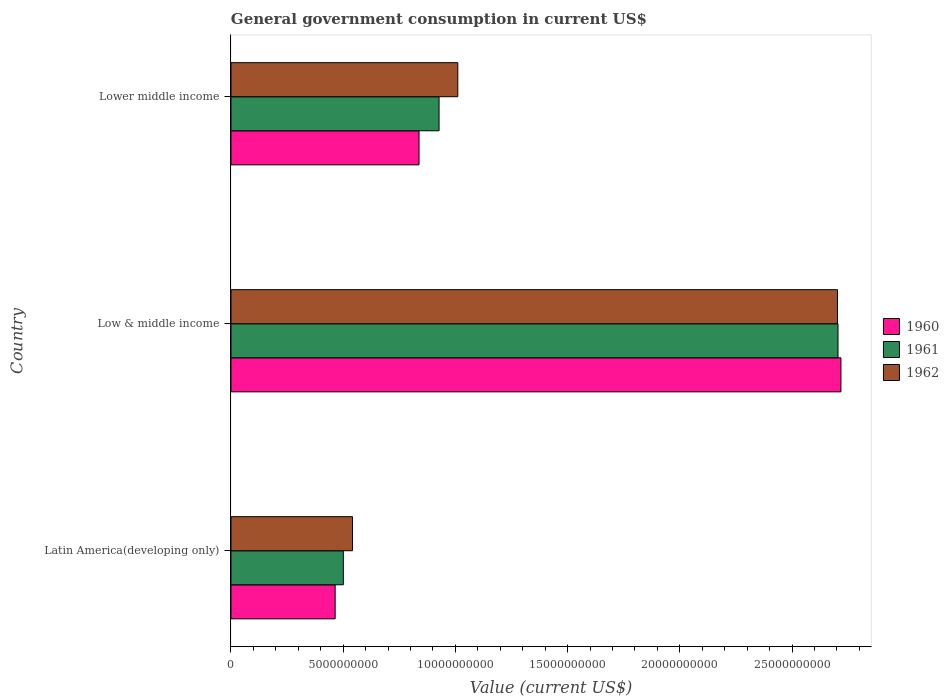How many different coloured bars are there?
Provide a short and direct response. 3. How many groups of bars are there?
Ensure brevity in your answer.  3. Are the number of bars per tick equal to the number of legend labels?
Offer a very short reply. Yes. How many bars are there on the 2nd tick from the top?
Make the answer very short. 3. How many bars are there on the 3rd tick from the bottom?
Provide a succinct answer. 3. What is the label of the 1st group of bars from the top?
Your answer should be very brief. Lower middle income. In how many cases, is the number of bars for a given country not equal to the number of legend labels?
Your answer should be very brief. 0. What is the government conusmption in 1962 in Latin America(developing only)?
Offer a terse response. 5.41e+09. Across all countries, what is the maximum government conusmption in 1960?
Your answer should be very brief. 2.72e+1. Across all countries, what is the minimum government conusmption in 1962?
Offer a terse response. 5.41e+09. In which country was the government conusmption in 1961 maximum?
Your answer should be very brief. Low & middle income. In which country was the government conusmption in 1960 minimum?
Give a very brief answer. Latin America(developing only). What is the total government conusmption in 1960 in the graph?
Keep it short and to the point. 4.02e+1. What is the difference between the government conusmption in 1960 in Latin America(developing only) and that in Lower middle income?
Offer a terse response. -3.74e+09. What is the difference between the government conusmption in 1961 in Latin America(developing only) and the government conusmption in 1962 in Low & middle income?
Ensure brevity in your answer.  -2.20e+1. What is the average government conusmption in 1962 per country?
Your answer should be very brief. 1.42e+1. What is the difference between the government conusmption in 1962 and government conusmption in 1961 in Latin America(developing only)?
Offer a terse response. 4.09e+08. What is the ratio of the government conusmption in 1961 in Low & middle income to that in Lower middle income?
Ensure brevity in your answer.  2.92. Is the government conusmption in 1962 in Low & middle income less than that in Lower middle income?
Give a very brief answer. No. Is the difference between the government conusmption in 1962 in Latin America(developing only) and Lower middle income greater than the difference between the government conusmption in 1961 in Latin America(developing only) and Lower middle income?
Your answer should be very brief. No. What is the difference between the highest and the second highest government conusmption in 1962?
Your answer should be compact. 1.69e+1. What is the difference between the highest and the lowest government conusmption in 1962?
Your response must be concise. 2.16e+1. In how many countries, is the government conusmption in 1960 greater than the average government conusmption in 1960 taken over all countries?
Make the answer very short. 1. Are all the bars in the graph horizontal?
Your answer should be compact. Yes. Are the values on the major ticks of X-axis written in scientific E-notation?
Ensure brevity in your answer.  No. Does the graph contain any zero values?
Your response must be concise. No. How are the legend labels stacked?
Give a very brief answer. Vertical. What is the title of the graph?
Give a very brief answer. General government consumption in current US$. What is the label or title of the X-axis?
Offer a terse response. Value (current US$). What is the Value (current US$) in 1960 in Latin America(developing only)?
Your answer should be compact. 4.64e+09. What is the Value (current US$) of 1961 in Latin America(developing only)?
Offer a terse response. 5.01e+09. What is the Value (current US$) in 1962 in Latin America(developing only)?
Offer a terse response. 5.41e+09. What is the Value (current US$) of 1960 in Low & middle income?
Provide a short and direct response. 2.72e+1. What is the Value (current US$) in 1961 in Low & middle income?
Keep it short and to the point. 2.70e+1. What is the Value (current US$) of 1962 in Low & middle income?
Make the answer very short. 2.70e+1. What is the Value (current US$) in 1960 in Lower middle income?
Ensure brevity in your answer.  8.38e+09. What is the Value (current US$) of 1961 in Lower middle income?
Offer a terse response. 9.27e+09. What is the Value (current US$) of 1962 in Lower middle income?
Ensure brevity in your answer.  1.01e+1. Across all countries, what is the maximum Value (current US$) in 1960?
Offer a terse response. 2.72e+1. Across all countries, what is the maximum Value (current US$) of 1961?
Your answer should be very brief. 2.70e+1. Across all countries, what is the maximum Value (current US$) of 1962?
Offer a very short reply. 2.70e+1. Across all countries, what is the minimum Value (current US$) in 1960?
Make the answer very short. 4.64e+09. Across all countries, what is the minimum Value (current US$) in 1961?
Your answer should be very brief. 5.01e+09. Across all countries, what is the minimum Value (current US$) of 1962?
Your answer should be very brief. 5.41e+09. What is the total Value (current US$) in 1960 in the graph?
Ensure brevity in your answer.  4.02e+1. What is the total Value (current US$) of 1961 in the graph?
Offer a terse response. 4.13e+1. What is the total Value (current US$) in 1962 in the graph?
Make the answer very short. 4.25e+1. What is the difference between the Value (current US$) in 1960 in Latin America(developing only) and that in Low & middle income?
Your response must be concise. -2.25e+1. What is the difference between the Value (current US$) of 1961 in Latin America(developing only) and that in Low & middle income?
Provide a succinct answer. -2.20e+1. What is the difference between the Value (current US$) of 1962 in Latin America(developing only) and that in Low & middle income?
Make the answer very short. -2.16e+1. What is the difference between the Value (current US$) in 1960 in Latin America(developing only) and that in Lower middle income?
Your answer should be very brief. -3.74e+09. What is the difference between the Value (current US$) in 1961 in Latin America(developing only) and that in Lower middle income?
Offer a terse response. -4.27e+09. What is the difference between the Value (current US$) of 1962 in Latin America(developing only) and that in Lower middle income?
Offer a very short reply. -4.69e+09. What is the difference between the Value (current US$) of 1960 in Low & middle income and that in Lower middle income?
Keep it short and to the point. 1.88e+1. What is the difference between the Value (current US$) of 1961 in Low & middle income and that in Lower middle income?
Offer a very short reply. 1.78e+1. What is the difference between the Value (current US$) in 1962 in Low & middle income and that in Lower middle income?
Provide a short and direct response. 1.69e+1. What is the difference between the Value (current US$) in 1960 in Latin America(developing only) and the Value (current US$) in 1961 in Low & middle income?
Your answer should be compact. -2.24e+1. What is the difference between the Value (current US$) of 1960 in Latin America(developing only) and the Value (current US$) of 1962 in Low & middle income?
Make the answer very short. -2.24e+1. What is the difference between the Value (current US$) of 1961 in Latin America(developing only) and the Value (current US$) of 1962 in Low & middle income?
Offer a very short reply. -2.20e+1. What is the difference between the Value (current US$) in 1960 in Latin America(developing only) and the Value (current US$) in 1961 in Lower middle income?
Provide a succinct answer. -4.63e+09. What is the difference between the Value (current US$) of 1960 in Latin America(developing only) and the Value (current US$) of 1962 in Lower middle income?
Your response must be concise. -5.46e+09. What is the difference between the Value (current US$) of 1961 in Latin America(developing only) and the Value (current US$) of 1962 in Lower middle income?
Make the answer very short. -5.10e+09. What is the difference between the Value (current US$) in 1960 in Low & middle income and the Value (current US$) in 1961 in Lower middle income?
Offer a terse response. 1.79e+1. What is the difference between the Value (current US$) in 1960 in Low & middle income and the Value (current US$) in 1962 in Lower middle income?
Provide a succinct answer. 1.71e+1. What is the difference between the Value (current US$) of 1961 in Low & middle income and the Value (current US$) of 1962 in Lower middle income?
Make the answer very short. 1.69e+1. What is the average Value (current US$) of 1960 per country?
Provide a succinct answer. 1.34e+1. What is the average Value (current US$) in 1961 per country?
Your response must be concise. 1.38e+1. What is the average Value (current US$) of 1962 per country?
Ensure brevity in your answer.  1.42e+1. What is the difference between the Value (current US$) of 1960 and Value (current US$) of 1961 in Latin America(developing only)?
Offer a terse response. -3.63e+08. What is the difference between the Value (current US$) of 1960 and Value (current US$) of 1962 in Latin America(developing only)?
Offer a very short reply. -7.72e+08. What is the difference between the Value (current US$) of 1961 and Value (current US$) of 1962 in Latin America(developing only)?
Your answer should be compact. -4.09e+08. What is the difference between the Value (current US$) in 1960 and Value (current US$) in 1961 in Low & middle income?
Ensure brevity in your answer.  1.30e+08. What is the difference between the Value (current US$) of 1960 and Value (current US$) of 1962 in Low & middle income?
Offer a terse response. 1.54e+08. What is the difference between the Value (current US$) in 1961 and Value (current US$) in 1962 in Low & middle income?
Give a very brief answer. 2.38e+07. What is the difference between the Value (current US$) of 1960 and Value (current US$) of 1961 in Lower middle income?
Ensure brevity in your answer.  -8.93e+08. What is the difference between the Value (current US$) in 1960 and Value (current US$) in 1962 in Lower middle income?
Your answer should be compact. -1.73e+09. What is the difference between the Value (current US$) in 1961 and Value (current US$) in 1962 in Lower middle income?
Offer a terse response. -8.35e+08. What is the ratio of the Value (current US$) in 1960 in Latin America(developing only) to that in Low & middle income?
Provide a succinct answer. 0.17. What is the ratio of the Value (current US$) in 1961 in Latin America(developing only) to that in Low & middle income?
Give a very brief answer. 0.19. What is the ratio of the Value (current US$) of 1962 in Latin America(developing only) to that in Low & middle income?
Provide a succinct answer. 0.2. What is the ratio of the Value (current US$) in 1960 in Latin America(developing only) to that in Lower middle income?
Give a very brief answer. 0.55. What is the ratio of the Value (current US$) of 1961 in Latin America(developing only) to that in Lower middle income?
Ensure brevity in your answer.  0.54. What is the ratio of the Value (current US$) of 1962 in Latin America(developing only) to that in Lower middle income?
Provide a short and direct response. 0.54. What is the ratio of the Value (current US$) of 1960 in Low & middle income to that in Lower middle income?
Ensure brevity in your answer.  3.24. What is the ratio of the Value (current US$) of 1961 in Low & middle income to that in Lower middle income?
Your response must be concise. 2.92. What is the ratio of the Value (current US$) in 1962 in Low & middle income to that in Lower middle income?
Your response must be concise. 2.67. What is the difference between the highest and the second highest Value (current US$) in 1960?
Ensure brevity in your answer.  1.88e+1. What is the difference between the highest and the second highest Value (current US$) in 1961?
Offer a very short reply. 1.78e+1. What is the difference between the highest and the second highest Value (current US$) in 1962?
Offer a terse response. 1.69e+1. What is the difference between the highest and the lowest Value (current US$) of 1960?
Make the answer very short. 2.25e+1. What is the difference between the highest and the lowest Value (current US$) of 1961?
Make the answer very short. 2.20e+1. What is the difference between the highest and the lowest Value (current US$) in 1962?
Your answer should be very brief. 2.16e+1. 